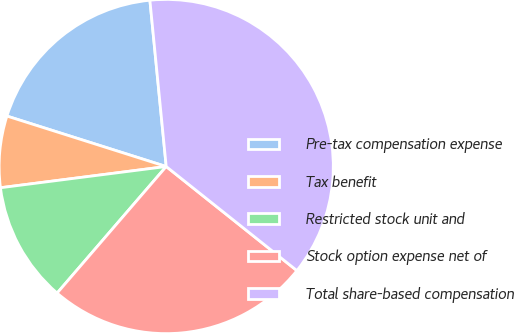Convert chart. <chart><loc_0><loc_0><loc_500><loc_500><pie_chart><fcel>Pre-tax compensation expense<fcel>Tax benefit<fcel>Restricted stock unit and<fcel>Stock option expense net of<fcel>Total share-based compensation<nl><fcel>18.56%<fcel>6.91%<fcel>11.65%<fcel>25.62%<fcel>37.26%<nl></chart> 